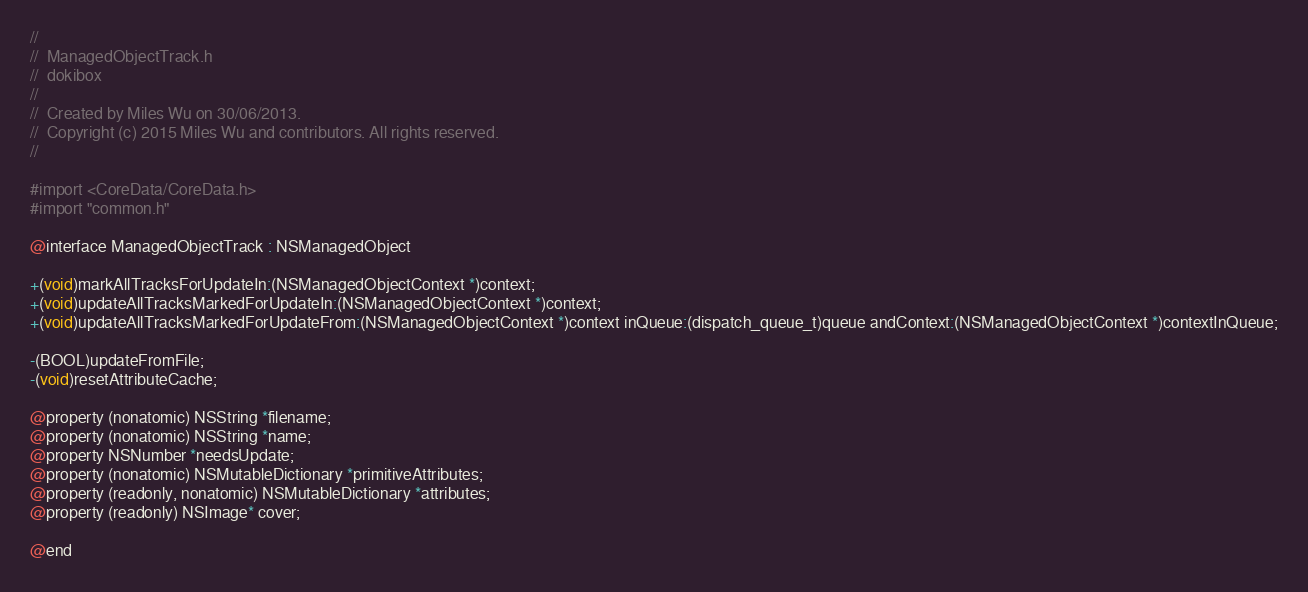Convert code to text. <code><loc_0><loc_0><loc_500><loc_500><_C_>//
//  ManagedObjectTrack.h
//  dokibox
//
//  Created by Miles Wu on 30/06/2013.
//  Copyright (c) 2015 Miles Wu and contributors. All rights reserved.
//

#import <CoreData/CoreData.h>
#import "common.h"

@interface ManagedObjectTrack : NSManagedObject

+(void)markAllTracksForUpdateIn:(NSManagedObjectContext *)context;
+(void)updateAllTracksMarkedForUpdateIn:(NSManagedObjectContext *)context;
+(void)updateAllTracksMarkedForUpdateFrom:(NSManagedObjectContext *)context inQueue:(dispatch_queue_t)queue andContext:(NSManagedObjectContext *)contextInQueue;

-(BOOL)updateFromFile;
-(void)resetAttributeCache;

@property (nonatomic) NSString *filename;
@property (nonatomic) NSString *name;
@property NSNumber *needsUpdate;
@property (nonatomic) NSMutableDictionary *primitiveAttributes;
@property (readonly, nonatomic) NSMutableDictionary *attributes;
@property (readonly) NSImage* cover;

@end
</code> 